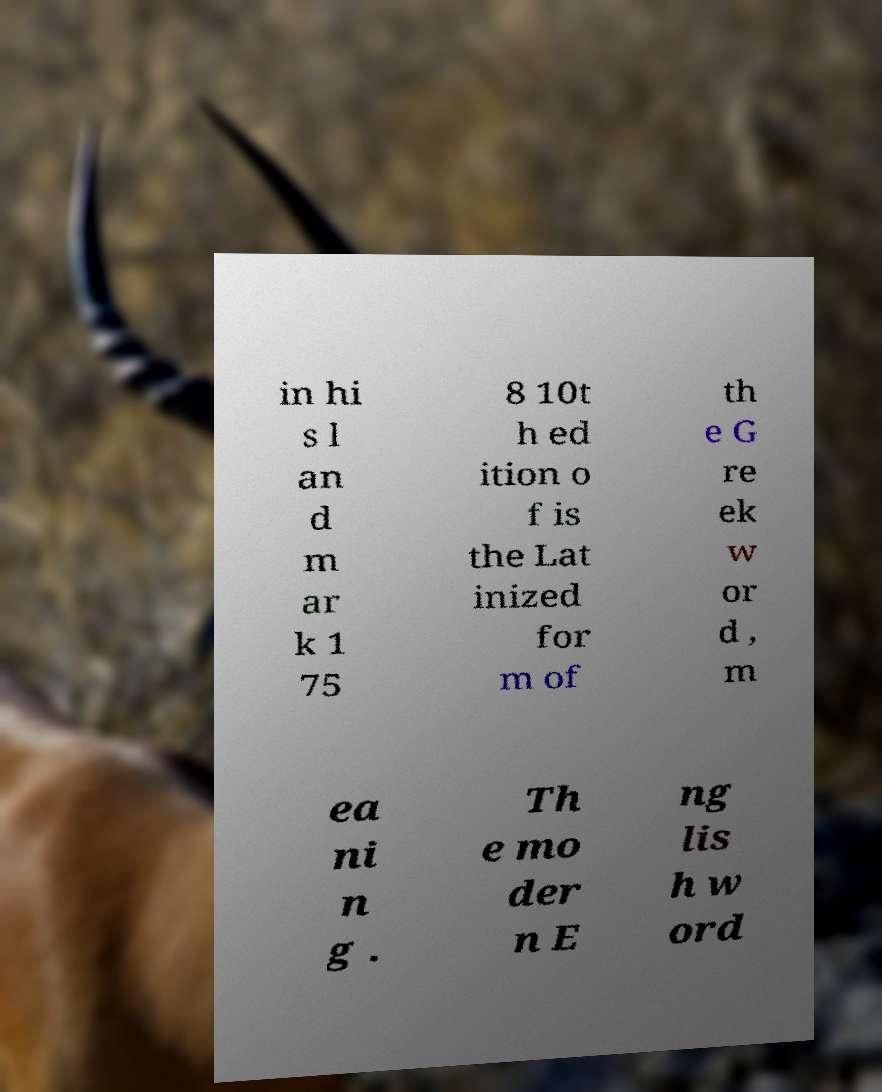For documentation purposes, I need the text within this image transcribed. Could you provide that? in hi s l an d m ar k 1 75 8 10t h ed ition o f is the Lat inized for m of th e G re ek w or d , m ea ni n g . Th e mo der n E ng lis h w ord 